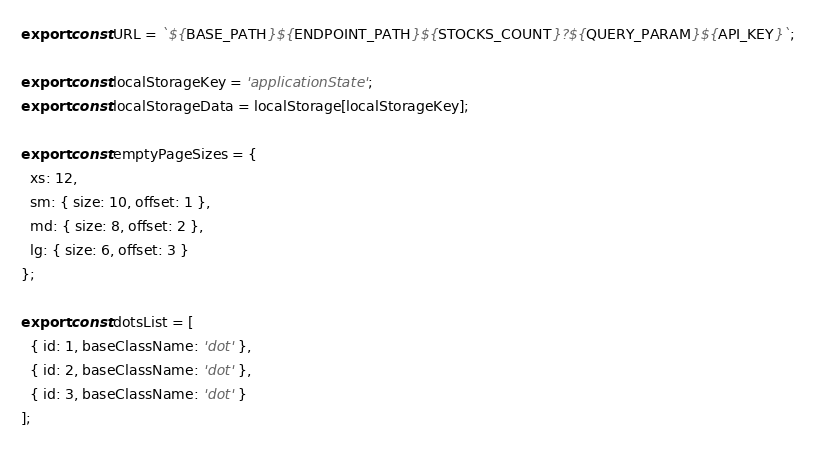<code> <loc_0><loc_0><loc_500><loc_500><_JavaScript_>export const URL = `${BASE_PATH}${ENDPOINT_PATH}${STOCKS_COUNT}?${QUERY_PARAM}${API_KEY}`;

export const localStorageKey = 'applicationState';
export const localStorageData = localStorage[localStorageKey];

export const emptyPageSizes = {
  xs: 12,
  sm: { size: 10, offset: 1 },
  md: { size: 8, offset: 2 },
  lg: { size: 6, offset: 3 }
};

export const dotsList = [
  { id: 1, baseClassName: 'dot' },
  { id: 2, baseClassName: 'dot' },
  { id: 3, baseClassName: 'dot' }
];
</code> 